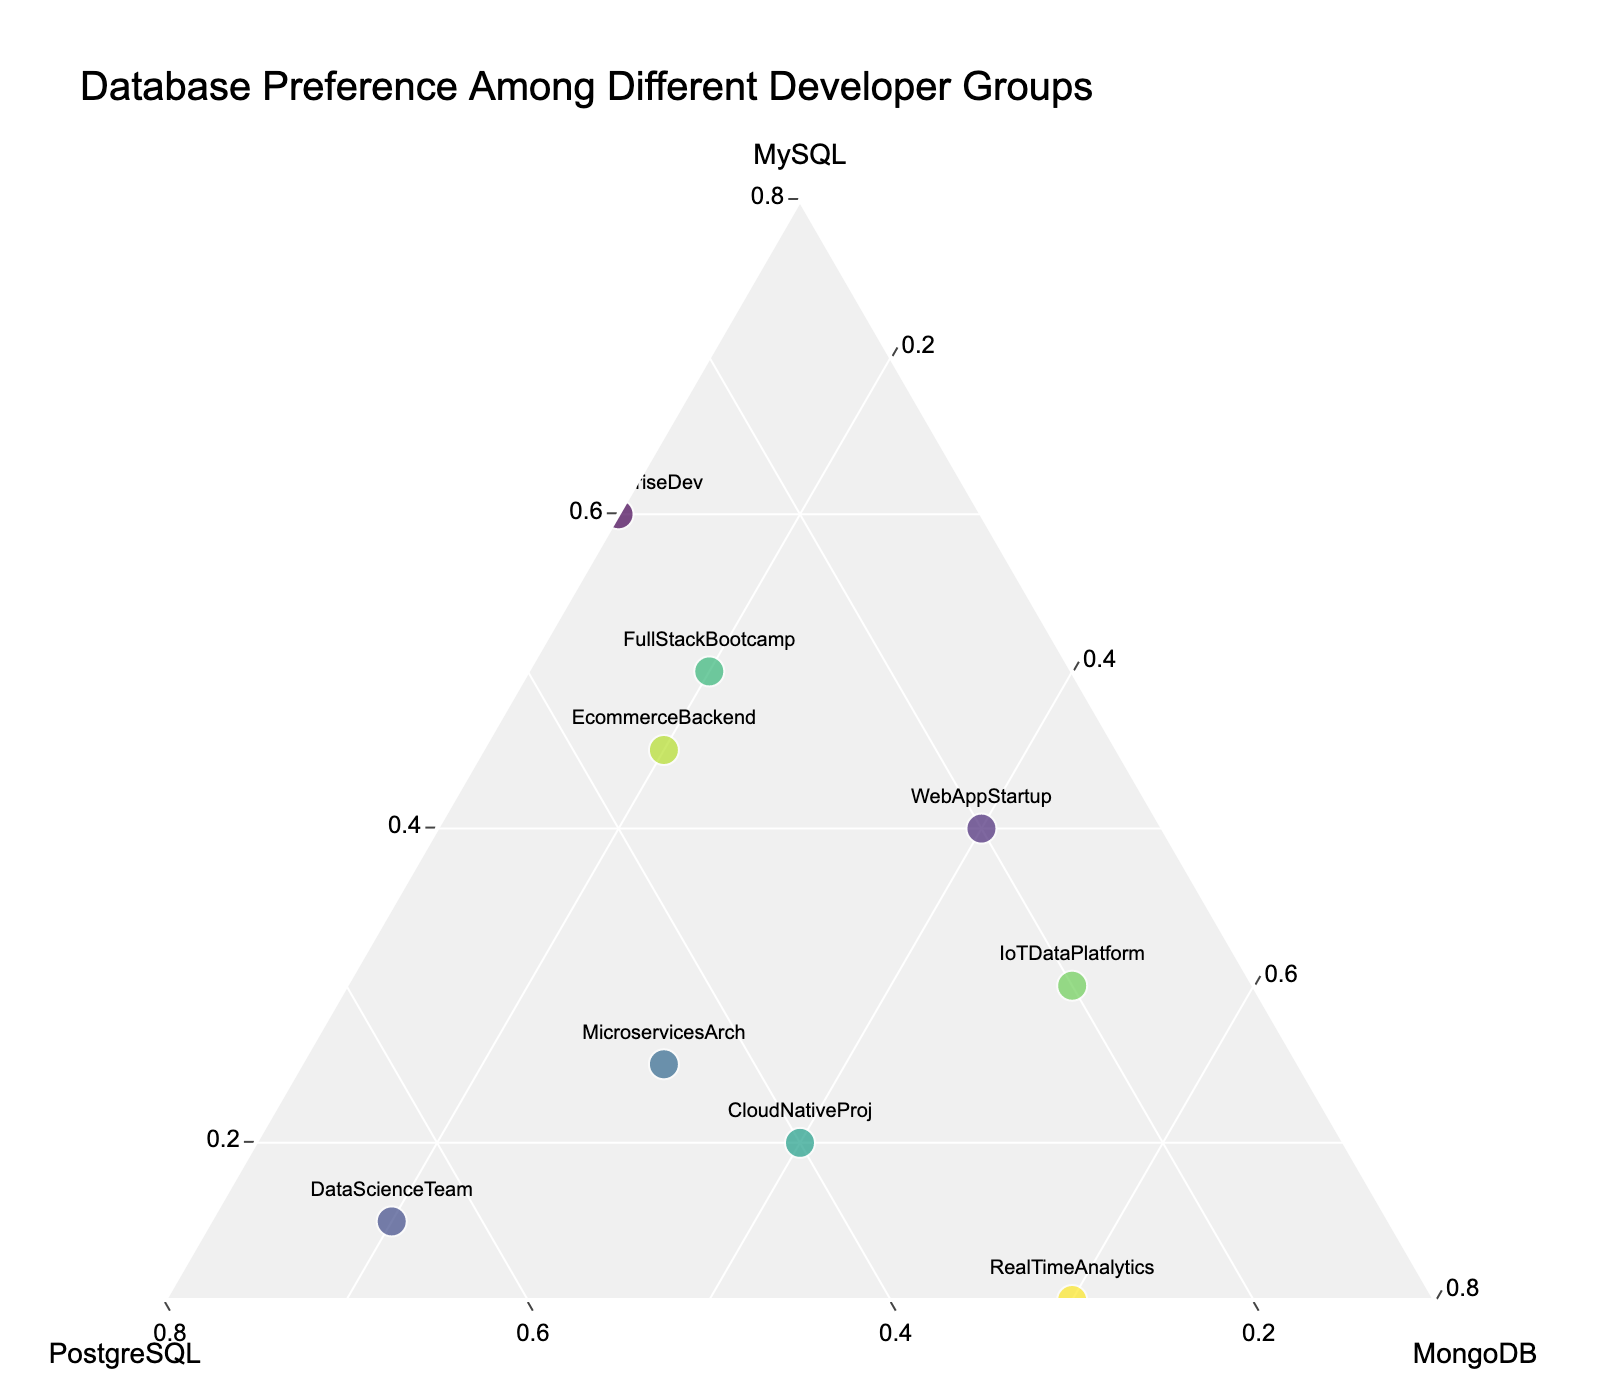What is the title of the ternary plot? The title is displayed at the top center of the plot. By looking at it directly, we can read the text.
Answer: Database Preference Among Different Developer Groups Which database does the 'RealTimeAnalytics' group prefer the most? Locate the 'RealTimeAnalytics' marker and observe its position within the ternary plot. It is situated closer to the MongoDB axis, indicating a higher preference for MongoDB.
Answer: MongoDB Which group shows a balanced preference toward MySQL and MongoDB? Identify the marker positions for each group. The 'WebAppStartup' and 'CloudNativeProj' groups are positioned closer to both MySQL and MongoDB than PostgreSQL, indicating a balanced preference between these two databases.
Answer: WebAppStartup, CloudNativeProj How many groups have at least 40% preference for PostgreSQL? Check the distribution of markers along the PostgreSQL axis. 'DataScienceTeam,' 'MicroservicesArch,' and 'CloudNativeProj' are positioned with coordinates indicating at least 40% preference for PostgreSQL.
Answer: 3 Are there any groups that have a higher preference for MySQL than any other database? Locate the markers that are closer to the MySQL axis than the other axes. The 'JavaEnterpriseDev,' 'LegacySystemMaint,' 'FullStackBootcamp,' and 'EcommerceBackend' have more than 50% preference for MySQL.
Answer: JavaEnterpriseDev, LegacySystemMaint, FullStackBootcamp, EcommerceBackend Which developer group shows the highest preference for MySQL? Observe the marker positions, focusing on the MySQL axis. 'LegacySystemMaint' has the highest value on the MySQL axis with 70%.
Answer: LegacySystemMaint What is the average preference for MongoDB among all developer groups? Add up the preferences for MongoDB from all groups and divide by the number of groups: (0.10 + 0.40 + 0.20 + 0.30 + 0.05 + 0.40 + 0.20 + 0.50 + 0.20 + 0.60) / 10 = 2.95 / 10.
Answer: 0.295 Which groups have a preference for PostgreSQL higher than their preference for MySQL? Compare the PostgreSQL and MySQL coordinates of each group. 'DataScienceTeam' and 'MicroservicesArch' have higher PostgreSQL preferences than MySQL.
Answer: DataScienceTeam, MicroservicesArch 